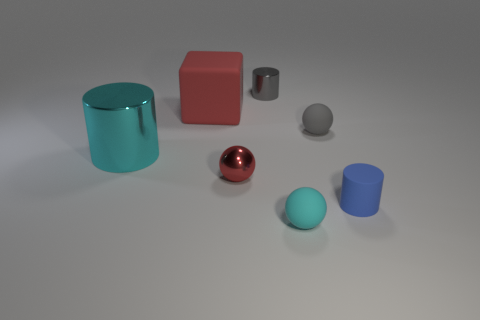What color is the other cylinder that is the same material as the cyan cylinder?
Offer a very short reply. Gray. How many small balls are the same material as the block?
Your answer should be compact. 2. Are there the same number of big matte blocks on the right side of the small gray ball and shiny objects that are behind the block?
Keep it short and to the point. No. There is a small gray metallic object; does it have the same shape as the tiny blue matte thing in front of the small gray matte ball?
Provide a short and direct response. Yes. There is a object that is the same color as the cube; what is its material?
Your answer should be very brief. Metal. Is there anything else that has the same shape as the red rubber object?
Keep it short and to the point. No. Does the tiny gray cylinder have the same material as the small thing that is in front of the small blue cylinder?
Your response must be concise. No. The metal cylinder behind the metal cylinder to the left of the tiny metal thing in front of the gray shiny cylinder is what color?
Ensure brevity in your answer.  Gray. Does the large rubber object have the same color as the tiny sphere on the left side of the cyan matte sphere?
Make the answer very short. Yes. What color is the rubber block?
Your answer should be compact. Red. 